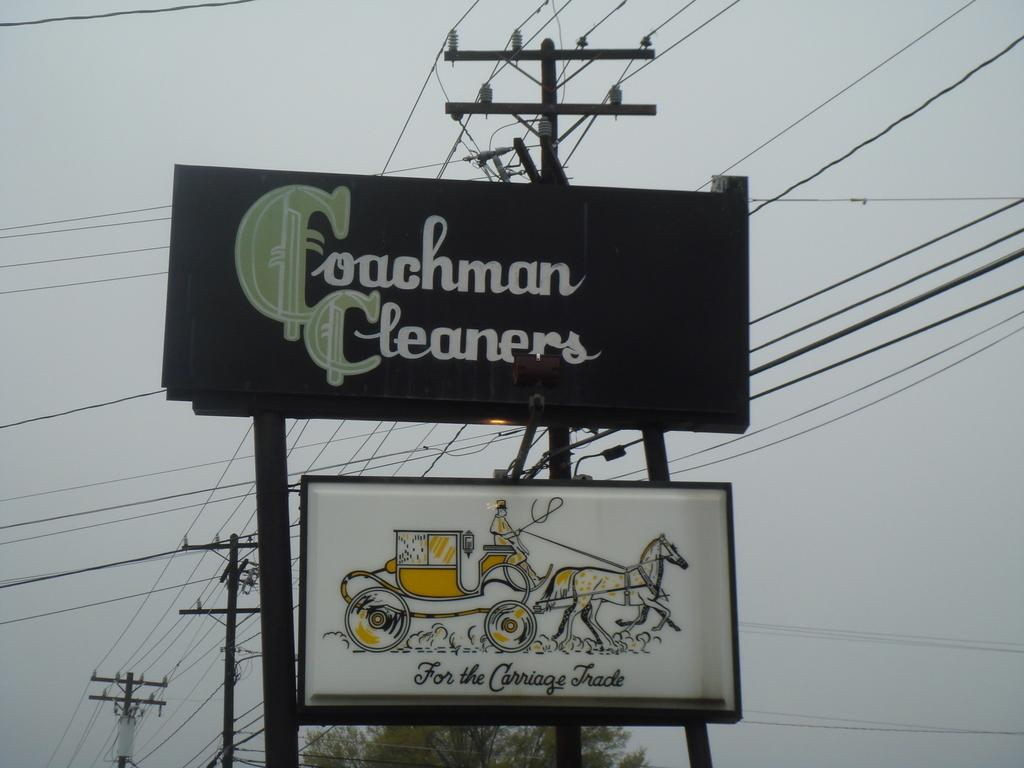<image>
Render a clear and concise summary of the photo. the word couchman cleaners is on the large black sign 